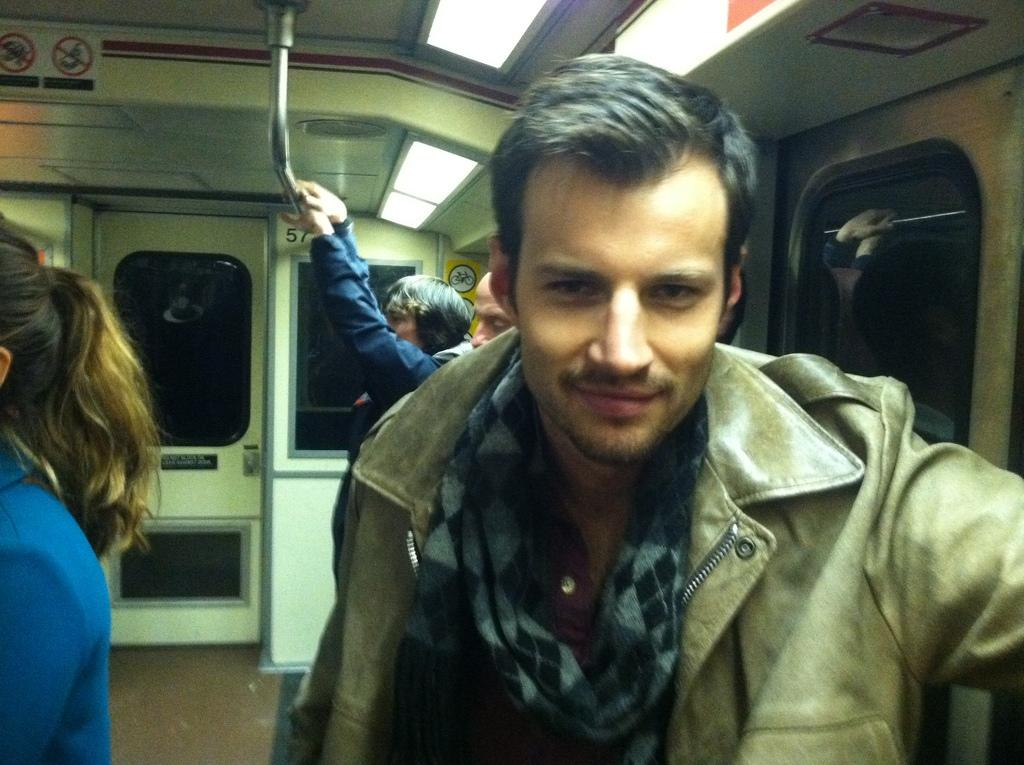What are the people in the image doing? The people in the image are standing in a train. Can you describe any specific objects or features in the background of the image? There is a person holding a metal rod in the background of the image. What can be seen through the windows in the image? There are lights visible in the image. How can people enter or exit the train in the image? There is a door visible in the image. What other objects or features can be seen in the image? There are other objects present in the image. Reasoning: Let's think step by step by step in order to produce the conversation. We start by identifying the main activity in the image, which is people standing in a train. Then, we expand the conversation to include other objects and features that are also visible, such as the metal rod, windows, lights, and a door. Each question is designed to elicit a specific detail about the image that is known from the provided facts. Absurd Question/Answer: What order is the train following in the image? There is no information about the train's order in the image. --- Facts: 1. There is a person sitting on a chair in the image. 2. The person is holding a book. 3. The book has a blue cover. 4. The chair is made of wood. 5. There is a table next to the chair. 6. On the table, there is a cup and a plate with cookies. Absurd Topics: elephant, ocean, sand Conversation: What is the person in the image doing? The person in the image is sitting on a chair and holding a book. Can you describe the book the person is holding? The book has a blue cover. What is the chair made of? The chair is made of wood. What can be seen on the table next to the chair? On the table next to the chair, there is a cup and a plate with cookies. Can you see any elephants or the ocean in the image? No, there are no elephants or the ocean present in the image. 